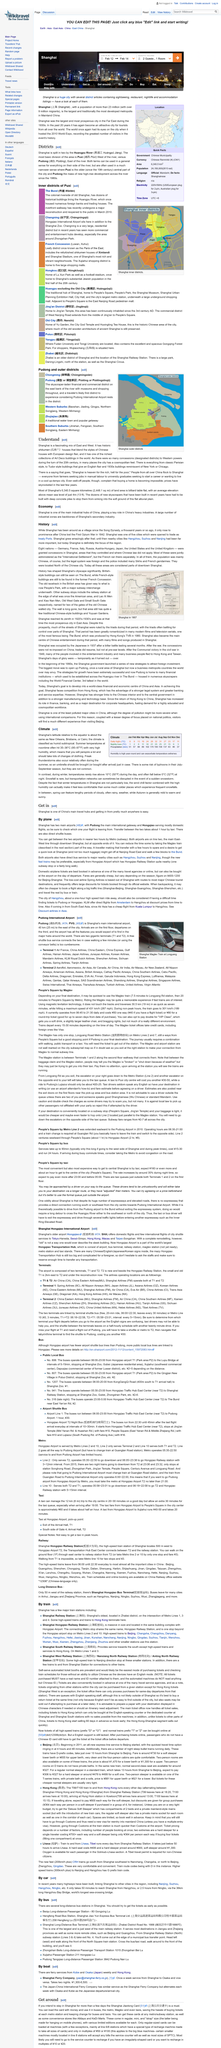Indicate a few pertinent items in this graphic. After the First Opium War in 1842, Shanghai became prominent. Eight outside nations were granted concessions within Shanghai because Shanghai was one of five cities opened as treaty ports. The eight nations that were granted concessions in Shanghai were Germany, France, Italy, Russia, Austria-Hungary, Japan, the USA, and the UK. 